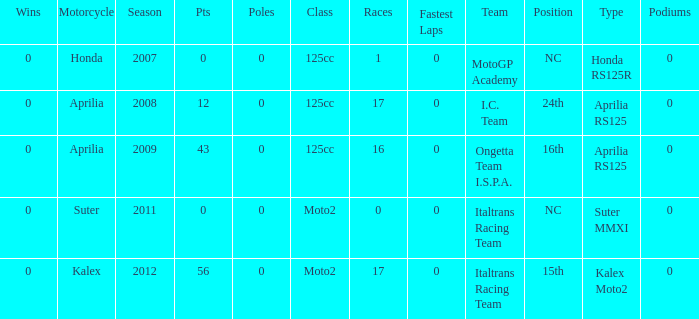What's the name of the team who had a Honda motorcycle? MotoGP Academy. 